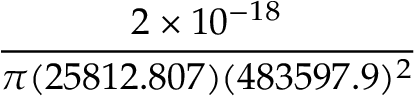Convert formula to latex. <formula><loc_0><loc_0><loc_500><loc_500>\frac { 2 \times 1 0 ^ { - 1 8 } } { \pi ( 2 5 8 1 2 . 8 0 7 ) ( 4 8 3 5 9 7 . 9 ) ^ { 2 } }</formula> 